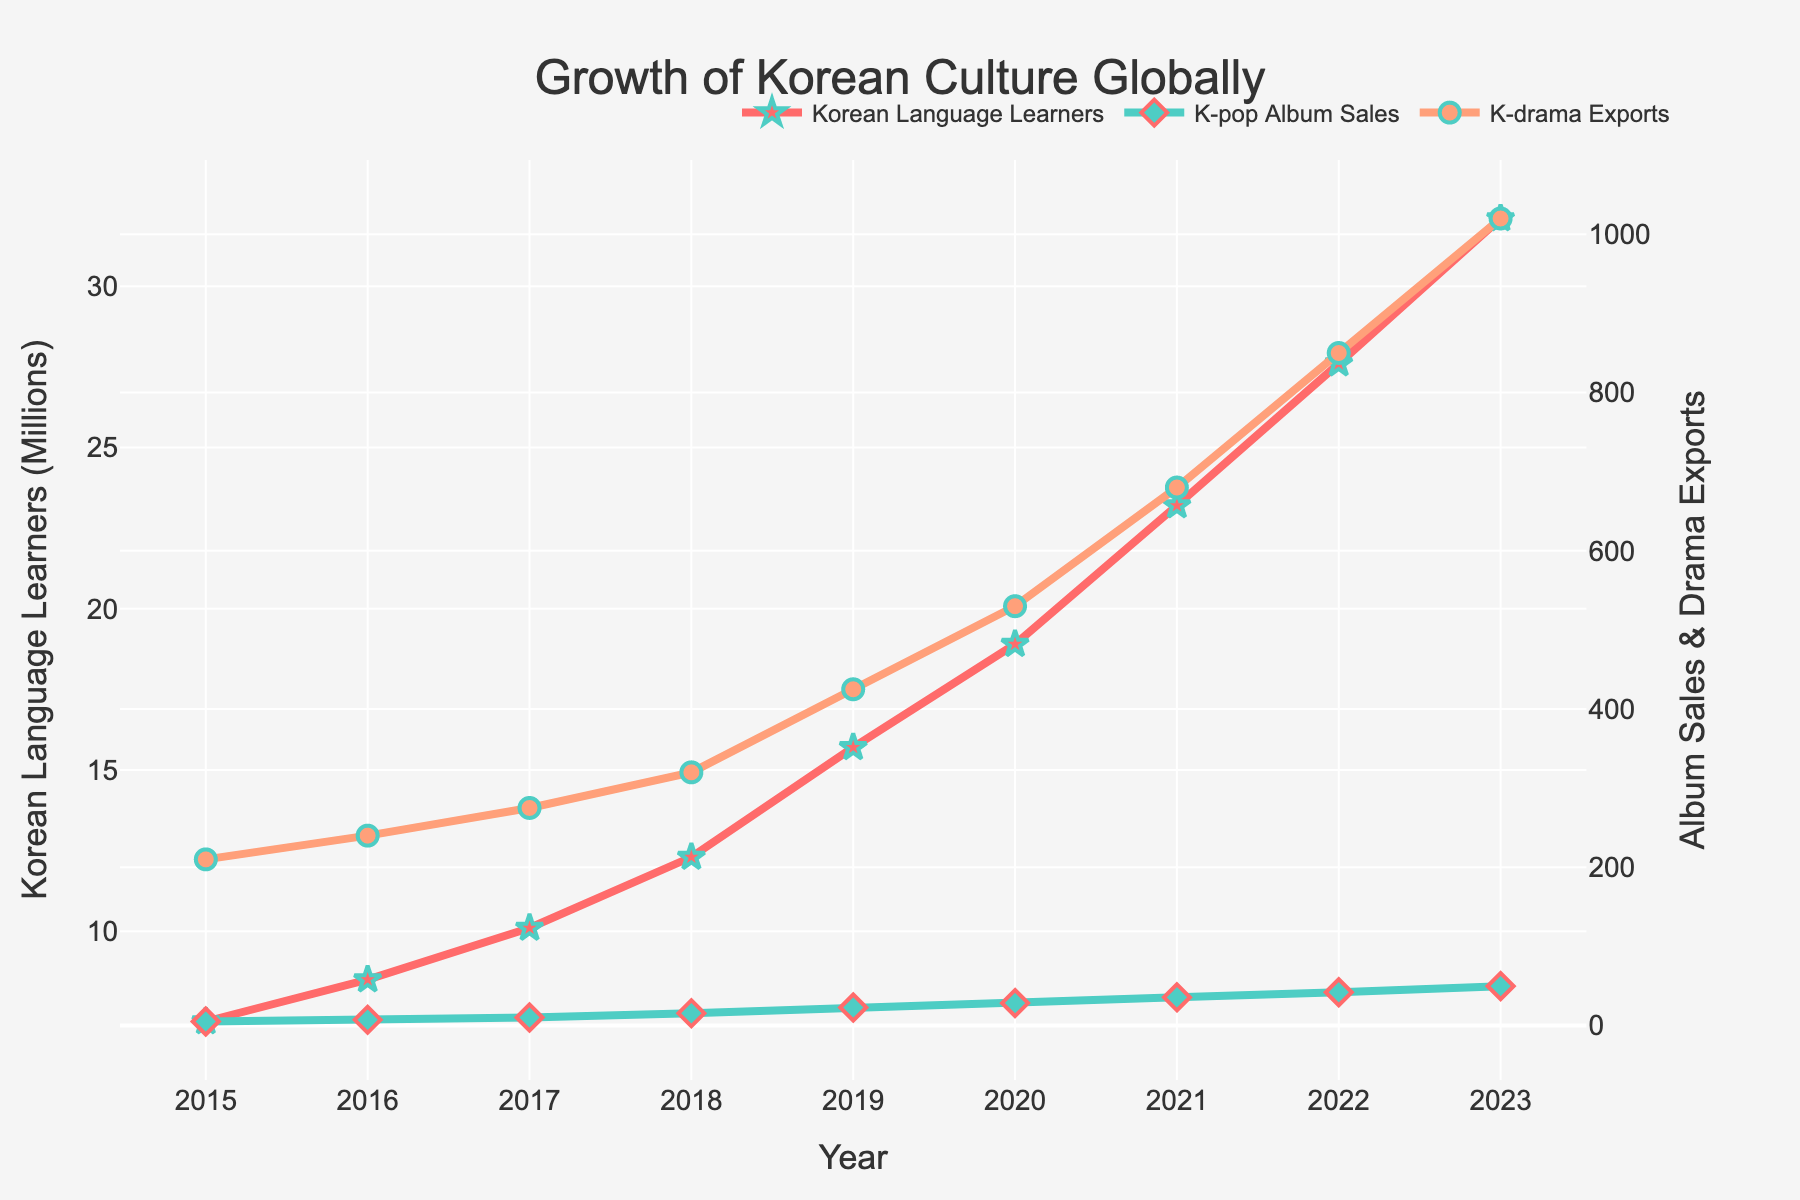What was the trend in the number of Global Korean Language Learners from 2015 to 2023? The number of Global Korean Language Learners shows a steady upward trend from 2015 to 2023, increasing each year without any decline.
Answer: Upward trend Which year saw the highest increase in K-pop Album Sales compared to the previous year? To determine the year with the highest increase, calculate the difference in K-pop Album Sales between consecutive years. From 2022 to 2023, sales increased from 42.1 million to 49.8 million, an increase of 7.7 million, which is the highest among all years.
Answer: 2023 How do the Global Korean Language Learners and K-drama Exports compare in terms of their growth rates from 2015 to 2023? To compare, observe the slopes of the lines representing both datasets. Both Global Korean Language Learners and K-drama Exports exhibit strong upward trends, but K-drama Exports show a steeper increase, indicating a higher growth rate.
Answer: K-drama Exports have a higher growth rate What was the approximate number of Korean Language Learners in the year when K-pop Album Sales reached approximately 15.5 million? Referring to the year 2018 (when K-pop Album Sales were around 15.5 million), the number of Korean Language Learners was approximately 12.3 million.
Answer: 12.3 million By how much did K-drama Exports increase from 2015 to 2023? Subtract the value of K-drama Exports in 2015 (210 million USD) from the value in 2023 (1020 million USD). The increase is 1020 - 210 = 810 million USD.
Answer: 810 million USD What is the average annual increase in Global Korean Language Learners from 2015 to 2023? Calculate the total increase (32.1 million in 2023 minus 7.2 million in 2015 = 24.9 million) and divide by the number of years (2023 - 2015 = 8 years). The average annual increase is 24.9 / 8 = 3.1125 million.
Answer: 3.1125 million In which year did K-drama Exports surpass 500 million USD? By checking the data for K-drama Exports, we see that they surpassed 500 million USD in 2020.
Answer: 2020 